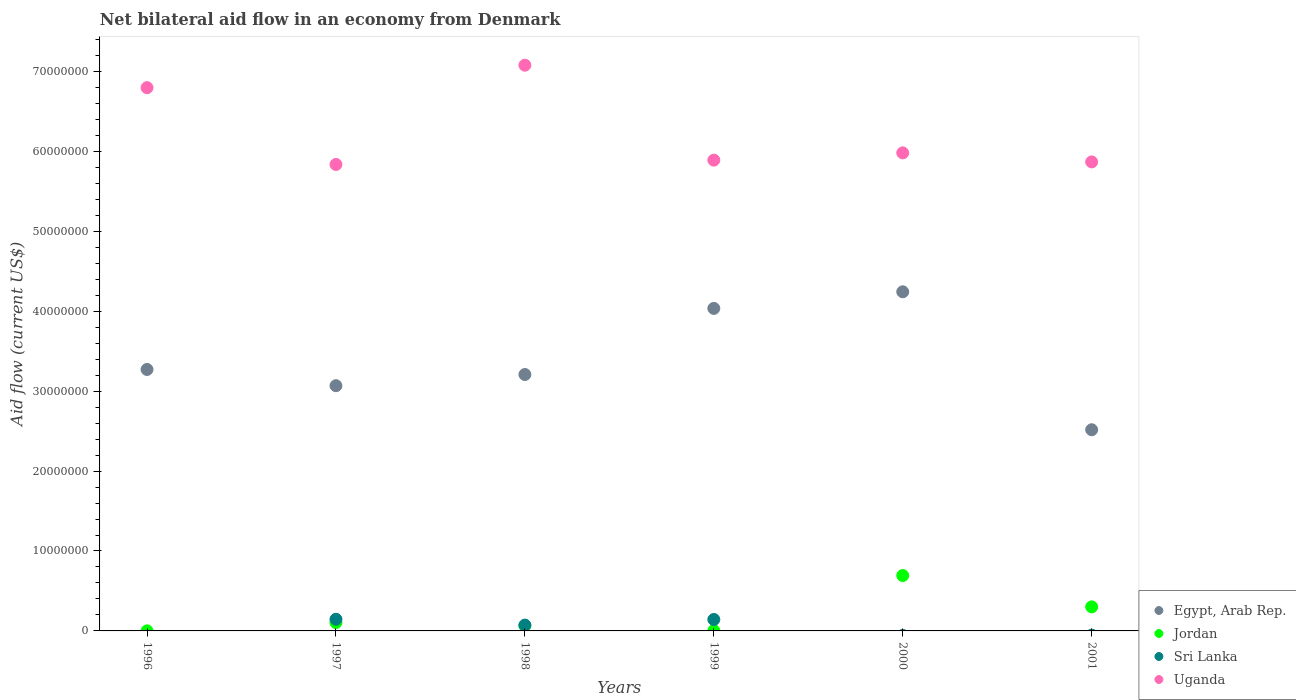How many different coloured dotlines are there?
Provide a short and direct response. 4. What is the net bilateral aid flow in Sri Lanka in 2000?
Keep it short and to the point. 0. Across all years, what is the maximum net bilateral aid flow in Uganda?
Your response must be concise. 7.08e+07. Across all years, what is the minimum net bilateral aid flow in Uganda?
Your answer should be compact. 5.84e+07. What is the total net bilateral aid flow in Jordan in the graph?
Offer a very short reply. 1.17e+07. What is the difference between the net bilateral aid flow in Egypt, Arab Rep. in 1999 and that in 2001?
Make the answer very short. 1.52e+07. What is the difference between the net bilateral aid flow in Uganda in 1999 and the net bilateral aid flow in Egypt, Arab Rep. in 2000?
Make the answer very short. 1.65e+07. What is the average net bilateral aid flow in Uganda per year?
Your answer should be very brief. 6.24e+07. In how many years, is the net bilateral aid flow in Uganda greater than 44000000 US$?
Offer a terse response. 6. What is the ratio of the net bilateral aid flow in Egypt, Arab Rep. in 1999 to that in 2000?
Your answer should be very brief. 0.95. Is the net bilateral aid flow in Egypt, Arab Rep. in 2000 less than that in 2001?
Give a very brief answer. No. Is the difference between the net bilateral aid flow in Sri Lanka in 1997 and 1999 greater than the difference between the net bilateral aid flow in Jordan in 1997 and 1999?
Provide a succinct answer. No. What is the difference between the highest and the second highest net bilateral aid flow in Sri Lanka?
Give a very brief answer. 3.00e+04. What is the difference between the highest and the lowest net bilateral aid flow in Sri Lanka?
Keep it short and to the point. 1.46e+06. In how many years, is the net bilateral aid flow in Sri Lanka greater than the average net bilateral aid flow in Sri Lanka taken over all years?
Make the answer very short. 3. Is it the case that in every year, the sum of the net bilateral aid flow in Jordan and net bilateral aid flow in Sri Lanka  is greater than the sum of net bilateral aid flow in Uganda and net bilateral aid flow in Egypt, Arab Rep.?
Provide a short and direct response. No. Is it the case that in every year, the sum of the net bilateral aid flow in Uganda and net bilateral aid flow in Sri Lanka  is greater than the net bilateral aid flow in Egypt, Arab Rep.?
Your answer should be very brief. Yes. Is the net bilateral aid flow in Egypt, Arab Rep. strictly greater than the net bilateral aid flow in Sri Lanka over the years?
Provide a succinct answer. Yes. How many dotlines are there?
Ensure brevity in your answer.  4. Does the graph contain grids?
Give a very brief answer. No. How many legend labels are there?
Ensure brevity in your answer.  4. What is the title of the graph?
Your answer should be very brief. Net bilateral aid flow in an economy from Denmark. What is the Aid flow (current US$) of Egypt, Arab Rep. in 1996?
Provide a succinct answer. 3.27e+07. What is the Aid flow (current US$) of Uganda in 1996?
Make the answer very short. 6.80e+07. What is the Aid flow (current US$) in Egypt, Arab Rep. in 1997?
Make the answer very short. 3.07e+07. What is the Aid flow (current US$) of Jordan in 1997?
Provide a short and direct response. 1.05e+06. What is the Aid flow (current US$) in Sri Lanka in 1997?
Provide a short and direct response. 1.46e+06. What is the Aid flow (current US$) of Uganda in 1997?
Ensure brevity in your answer.  5.84e+07. What is the Aid flow (current US$) in Egypt, Arab Rep. in 1998?
Your response must be concise. 3.21e+07. What is the Aid flow (current US$) in Jordan in 1998?
Provide a short and direct response. 6.50e+05. What is the Aid flow (current US$) in Sri Lanka in 1998?
Your response must be concise. 7.30e+05. What is the Aid flow (current US$) in Uganda in 1998?
Keep it short and to the point. 7.08e+07. What is the Aid flow (current US$) of Egypt, Arab Rep. in 1999?
Give a very brief answer. 4.04e+07. What is the Aid flow (current US$) in Jordan in 1999?
Your answer should be very brief. 4.00e+04. What is the Aid flow (current US$) of Sri Lanka in 1999?
Your response must be concise. 1.43e+06. What is the Aid flow (current US$) in Uganda in 1999?
Offer a terse response. 5.89e+07. What is the Aid flow (current US$) in Egypt, Arab Rep. in 2000?
Your answer should be very brief. 4.24e+07. What is the Aid flow (current US$) of Jordan in 2000?
Make the answer very short. 6.93e+06. What is the Aid flow (current US$) in Sri Lanka in 2000?
Offer a very short reply. 0. What is the Aid flow (current US$) in Uganda in 2000?
Ensure brevity in your answer.  5.98e+07. What is the Aid flow (current US$) in Egypt, Arab Rep. in 2001?
Provide a succinct answer. 2.52e+07. What is the Aid flow (current US$) in Jordan in 2001?
Make the answer very short. 3.01e+06. What is the Aid flow (current US$) of Sri Lanka in 2001?
Your answer should be compact. 0. What is the Aid flow (current US$) of Uganda in 2001?
Provide a short and direct response. 5.87e+07. Across all years, what is the maximum Aid flow (current US$) of Egypt, Arab Rep.?
Your answer should be compact. 4.24e+07. Across all years, what is the maximum Aid flow (current US$) in Jordan?
Your response must be concise. 6.93e+06. Across all years, what is the maximum Aid flow (current US$) in Sri Lanka?
Offer a very short reply. 1.46e+06. Across all years, what is the maximum Aid flow (current US$) of Uganda?
Provide a succinct answer. 7.08e+07. Across all years, what is the minimum Aid flow (current US$) of Egypt, Arab Rep.?
Your response must be concise. 2.52e+07. Across all years, what is the minimum Aid flow (current US$) in Sri Lanka?
Provide a short and direct response. 0. Across all years, what is the minimum Aid flow (current US$) of Uganda?
Give a very brief answer. 5.84e+07. What is the total Aid flow (current US$) of Egypt, Arab Rep. in the graph?
Your response must be concise. 2.03e+08. What is the total Aid flow (current US$) of Jordan in the graph?
Make the answer very short. 1.17e+07. What is the total Aid flow (current US$) of Sri Lanka in the graph?
Your response must be concise. 3.62e+06. What is the total Aid flow (current US$) in Uganda in the graph?
Offer a terse response. 3.74e+08. What is the difference between the Aid flow (current US$) of Egypt, Arab Rep. in 1996 and that in 1997?
Your answer should be very brief. 2.03e+06. What is the difference between the Aid flow (current US$) of Jordan in 1996 and that in 1997?
Your answer should be compact. -1.04e+06. What is the difference between the Aid flow (current US$) of Uganda in 1996 and that in 1997?
Give a very brief answer. 9.61e+06. What is the difference between the Aid flow (current US$) in Egypt, Arab Rep. in 1996 and that in 1998?
Your answer should be compact. 6.30e+05. What is the difference between the Aid flow (current US$) of Jordan in 1996 and that in 1998?
Your response must be concise. -6.40e+05. What is the difference between the Aid flow (current US$) of Uganda in 1996 and that in 1998?
Offer a very short reply. -2.81e+06. What is the difference between the Aid flow (current US$) of Egypt, Arab Rep. in 1996 and that in 1999?
Your answer should be very brief. -7.64e+06. What is the difference between the Aid flow (current US$) of Uganda in 1996 and that in 1999?
Make the answer very short. 9.07e+06. What is the difference between the Aid flow (current US$) in Egypt, Arab Rep. in 1996 and that in 2000?
Give a very brief answer. -9.72e+06. What is the difference between the Aid flow (current US$) in Jordan in 1996 and that in 2000?
Make the answer very short. -6.92e+06. What is the difference between the Aid flow (current US$) in Uganda in 1996 and that in 2000?
Offer a very short reply. 8.16e+06. What is the difference between the Aid flow (current US$) of Egypt, Arab Rep. in 1996 and that in 2001?
Ensure brevity in your answer.  7.54e+06. What is the difference between the Aid flow (current US$) of Jordan in 1996 and that in 2001?
Your response must be concise. -3.00e+06. What is the difference between the Aid flow (current US$) of Uganda in 1996 and that in 2001?
Your answer should be compact. 9.29e+06. What is the difference between the Aid flow (current US$) of Egypt, Arab Rep. in 1997 and that in 1998?
Provide a succinct answer. -1.40e+06. What is the difference between the Aid flow (current US$) in Sri Lanka in 1997 and that in 1998?
Your answer should be compact. 7.30e+05. What is the difference between the Aid flow (current US$) in Uganda in 1997 and that in 1998?
Give a very brief answer. -1.24e+07. What is the difference between the Aid flow (current US$) in Egypt, Arab Rep. in 1997 and that in 1999?
Offer a very short reply. -9.67e+06. What is the difference between the Aid flow (current US$) of Jordan in 1997 and that in 1999?
Keep it short and to the point. 1.01e+06. What is the difference between the Aid flow (current US$) in Uganda in 1997 and that in 1999?
Ensure brevity in your answer.  -5.40e+05. What is the difference between the Aid flow (current US$) in Egypt, Arab Rep. in 1997 and that in 2000?
Your response must be concise. -1.18e+07. What is the difference between the Aid flow (current US$) of Jordan in 1997 and that in 2000?
Give a very brief answer. -5.88e+06. What is the difference between the Aid flow (current US$) of Uganda in 1997 and that in 2000?
Offer a very short reply. -1.45e+06. What is the difference between the Aid flow (current US$) in Egypt, Arab Rep. in 1997 and that in 2001?
Give a very brief answer. 5.51e+06. What is the difference between the Aid flow (current US$) of Jordan in 1997 and that in 2001?
Offer a terse response. -1.96e+06. What is the difference between the Aid flow (current US$) in Uganda in 1997 and that in 2001?
Offer a terse response. -3.20e+05. What is the difference between the Aid flow (current US$) in Egypt, Arab Rep. in 1998 and that in 1999?
Provide a succinct answer. -8.27e+06. What is the difference between the Aid flow (current US$) in Jordan in 1998 and that in 1999?
Your response must be concise. 6.10e+05. What is the difference between the Aid flow (current US$) of Sri Lanka in 1998 and that in 1999?
Offer a very short reply. -7.00e+05. What is the difference between the Aid flow (current US$) in Uganda in 1998 and that in 1999?
Provide a short and direct response. 1.19e+07. What is the difference between the Aid flow (current US$) in Egypt, Arab Rep. in 1998 and that in 2000?
Give a very brief answer. -1.04e+07. What is the difference between the Aid flow (current US$) of Jordan in 1998 and that in 2000?
Provide a succinct answer. -6.28e+06. What is the difference between the Aid flow (current US$) of Uganda in 1998 and that in 2000?
Provide a short and direct response. 1.10e+07. What is the difference between the Aid flow (current US$) in Egypt, Arab Rep. in 1998 and that in 2001?
Ensure brevity in your answer.  6.91e+06. What is the difference between the Aid flow (current US$) of Jordan in 1998 and that in 2001?
Give a very brief answer. -2.36e+06. What is the difference between the Aid flow (current US$) of Uganda in 1998 and that in 2001?
Your answer should be compact. 1.21e+07. What is the difference between the Aid flow (current US$) of Egypt, Arab Rep. in 1999 and that in 2000?
Your answer should be compact. -2.08e+06. What is the difference between the Aid flow (current US$) of Jordan in 1999 and that in 2000?
Offer a terse response. -6.89e+06. What is the difference between the Aid flow (current US$) of Uganda in 1999 and that in 2000?
Ensure brevity in your answer.  -9.10e+05. What is the difference between the Aid flow (current US$) of Egypt, Arab Rep. in 1999 and that in 2001?
Your answer should be compact. 1.52e+07. What is the difference between the Aid flow (current US$) in Jordan in 1999 and that in 2001?
Your response must be concise. -2.97e+06. What is the difference between the Aid flow (current US$) in Uganda in 1999 and that in 2001?
Provide a short and direct response. 2.20e+05. What is the difference between the Aid flow (current US$) of Egypt, Arab Rep. in 2000 and that in 2001?
Offer a very short reply. 1.73e+07. What is the difference between the Aid flow (current US$) of Jordan in 2000 and that in 2001?
Make the answer very short. 3.92e+06. What is the difference between the Aid flow (current US$) in Uganda in 2000 and that in 2001?
Your answer should be compact. 1.13e+06. What is the difference between the Aid flow (current US$) of Egypt, Arab Rep. in 1996 and the Aid flow (current US$) of Jordan in 1997?
Make the answer very short. 3.17e+07. What is the difference between the Aid flow (current US$) in Egypt, Arab Rep. in 1996 and the Aid flow (current US$) in Sri Lanka in 1997?
Give a very brief answer. 3.12e+07. What is the difference between the Aid flow (current US$) of Egypt, Arab Rep. in 1996 and the Aid flow (current US$) of Uganda in 1997?
Your answer should be very brief. -2.56e+07. What is the difference between the Aid flow (current US$) in Jordan in 1996 and the Aid flow (current US$) in Sri Lanka in 1997?
Make the answer very short. -1.45e+06. What is the difference between the Aid flow (current US$) in Jordan in 1996 and the Aid flow (current US$) in Uganda in 1997?
Your response must be concise. -5.84e+07. What is the difference between the Aid flow (current US$) in Egypt, Arab Rep. in 1996 and the Aid flow (current US$) in Jordan in 1998?
Offer a very short reply. 3.21e+07. What is the difference between the Aid flow (current US$) of Egypt, Arab Rep. in 1996 and the Aid flow (current US$) of Sri Lanka in 1998?
Provide a short and direct response. 3.20e+07. What is the difference between the Aid flow (current US$) of Egypt, Arab Rep. in 1996 and the Aid flow (current US$) of Uganda in 1998?
Keep it short and to the point. -3.81e+07. What is the difference between the Aid flow (current US$) in Jordan in 1996 and the Aid flow (current US$) in Sri Lanka in 1998?
Ensure brevity in your answer.  -7.20e+05. What is the difference between the Aid flow (current US$) of Jordan in 1996 and the Aid flow (current US$) of Uganda in 1998?
Offer a terse response. -7.08e+07. What is the difference between the Aid flow (current US$) of Egypt, Arab Rep. in 1996 and the Aid flow (current US$) of Jordan in 1999?
Keep it short and to the point. 3.27e+07. What is the difference between the Aid flow (current US$) in Egypt, Arab Rep. in 1996 and the Aid flow (current US$) in Sri Lanka in 1999?
Your answer should be very brief. 3.13e+07. What is the difference between the Aid flow (current US$) in Egypt, Arab Rep. in 1996 and the Aid flow (current US$) in Uganda in 1999?
Your response must be concise. -2.62e+07. What is the difference between the Aid flow (current US$) of Jordan in 1996 and the Aid flow (current US$) of Sri Lanka in 1999?
Offer a terse response. -1.42e+06. What is the difference between the Aid flow (current US$) of Jordan in 1996 and the Aid flow (current US$) of Uganda in 1999?
Keep it short and to the point. -5.89e+07. What is the difference between the Aid flow (current US$) of Egypt, Arab Rep. in 1996 and the Aid flow (current US$) of Jordan in 2000?
Your answer should be compact. 2.58e+07. What is the difference between the Aid flow (current US$) of Egypt, Arab Rep. in 1996 and the Aid flow (current US$) of Uganda in 2000?
Make the answer very short. -2.71e+07. What is the difference between the Aid flow (current US$) in Jordan in 1996 and the Aid flow (current US$) in Uganda in 2000?
Provide a short and direct response. -5.98e+07. What is the difference between the Aid flow (current US$) in Egypt, Arab Rep. in 1996 and the Aid flow (current US$) in Jordan in 2001?
Offer a terse response. 2.97e+07. What is the difference between the Aid flow (current US$) of Egypt, Arab Rep. in 1996 and the Aid flow (current US$) of Uganda in 2001?
Your answer should be very brief. -2.60e+07. What is the difference between the Aid flow (current US$) of Jordan in 1996 and the Aid flow (current US$) of Uganda in 2001?
Your response must be concise. -5.87e+07. What is the difference between the Aid flow (current US$) in Egypt, Arab Rep. in 1997 and the Aid flow (current US$) in Jordan in 1998?
Keep it short and to the point. 3.00e+07. What is the difference between the Aid flow (current US$) in Egypt, Arab Rep. in 1997 and the Aid flow (current US$) in Sri Lanka in 1998?
Your answer should be compact. 3.00e+07. What is the difference between the Aid flow (current US$) of Egypt, Arab Rep. in 1997 and the Aid flow (current US$) of Uganda in 1998?
Ensure brevity in your answer.  -4.01e+07. What is the difference between the Aid flow (current US$) of Jordan in 1997 and the Aid flow (current US$) of Uganda in 1998?
Offer a very short reply. -6.97e+07. What is the difference between the Aid flow (current US$) of Sri Lanka in 1997 and the Aid flow (current US$) of Uganda in 1998?
Your answer should be very brief. -6.93e+07. What is the difference between the Aid flow (current US$) in Egypt, Arab Rep. in 1997 and the Aid flow (current US$) in Jordan in 1999?
Provide a short and direct response. 3.06e+07. What is the difference between the Aid flow (current US$) of Egypt, Arab Rep. in 1997 and the Aid flow (current US$) of Sri Lanka in 1999?
Make the answer very short. 2.92e+07. What is the difference between the Aid flow (current US$) in Egypt, Arab Rep. in 1997 and the Aid flow (current US$) in Uganda in 1999?
Offer a terse response. -2.82e+07. What is the difference between the Aid flow (current US$) of Jordan in 1997 and the Aid flow (current US$) of Sri Lanka in 1999?
Provide a short and direct response. -3.80e+05. What is the difference between the Aid flow (current US$) in Jordan in 1997 and the Aid flow (current US$) in Uganda in 1999?
Offer a very short reply. -5.78e+07. What is the difference between the Aid flow (current US$) in Sri Lanka in 1997 and the Aid flow (current US$) in Uganda in 1999?
Provide a short and direct response. -5.74e+07. What is the difference between the Aid flow (current US$) in Egypt, Arab Rep. in 1997 and the Aid flow (current US$) in Jordan in 2000?
Offer a very short reply. 2.38e+07. What is the difference between the Aid flow (current US$) of Egypt, Arab Rep. in 1997 and the Aid flow (current US$) of Uganda in 2000?
Provide a short and direct response. -2.91e+07. What is the difference between the Aid flow (current US$) in Jordan in 1997 and the Aid flow (current US$) in Uganda in 2000?
Your response must be concise. -5.88e+07. What is the difference between the Aid flow (current US$) in Sri Lanka in 1997 and the Aid flow (current US$) in Uganda in 2000?
Make the answer very short. -5.84e+07. What is the difference between the Aid flow (current US$) in Egypt, Arab Rep. in 1997 and the Aid flow (current US$) in Jordan in 2001?
Offer a terse response. 2.77e+07. What is the difference between the Aid flow (current US$) of Egypt, Arab Rep. in 1997 and the Aid flow (current US$) of Uganda in 2001?
Your answer should be very brief. -2.80e+07. What is the difference between the Aid flow (current US$) in Jordan in 1997 and the Aid flow (current US$) in Uganda in 2001?
Give a very brief answer. -5.76e+07. What is the difference between the Aid flow (current US$) in Sri Lanka in 1997 and the Aid flow (current US$) in Uganda in 2001?
Provide a short and direct response. -5.72e+07. What is the difference between the Aid flow (current US$) in Egypt, Arab Rep. in 1998 and the Aid flow (current US$) in Jordan in 1999?
Your answer should be very brief. 3.20e+07. What is the difference between the Aid flow (current US$) in Egypt, Arab Rep. in 1998 and the Aid flow (current US$) in Sri Lanka in 1999?
Ensure brevity in your answer.  3.06e+07. What is the difference between the Aid flow (current US$) in Egypt, Arab Rep. in 1998 and the Aid flow (current US$) in Uganda in 1999?
Provide a short and direct response. -2.68e+07. What is the difference between the Aid flow (current US$) in Jordan in 1998 and the Aid flow (current US$) in Sri Lanka in 1999?
Provide a short and direct response. -7.80e+05. What is the difference between the Aid flow (current US$) of Jordan in 1998 and the Aid flow (current US$) of Uganda in 1999?
Ensure brevity in your answer.  -5.82e+07. What is the difference between the Aid flow (current US$) of Sri Lanka in 1998 and the Aid flow (current US$) of Uganda in 1999?
Your response must be concise. -5.82e+07. What is the difference between the Aid flow (current US$) in Egypt, Arab Rep. in 1998 and the Aid flow (current US$) in Jordan in 2000?
Provide a succinct answer. 2.52e+07. What is the difference between the Aid flow (current US$) in Egypt, Arab Rep. in 1998 and the Aid flow (current US$) in Uganda in 2000?
Your answer should be compact. -2.77e+07. What is the difference between the Aid flow (current US$) in Jordan in 1998 and the Aid flow (current US$) in Uganda in 2000?
Keep it short and to the point. -5.92e+07. What is the difference between the Aid flow (current US$) in Sri Lanka in 1998 and the Aid flow (current US$) in Uganda in 2000?
Provide a short and direct response. -5.91e+07. What is the difference between the Aid flow (current US$) in Egypt, Arab Rep. in 1998 and the Aid flow (current US$) in Jordan in 2001?
Your answer should be very brief. 2.91e+07. What is the difference between the Aid flow (current US$) in Egypt, Arab Rep. in 1998 and the Aid flow (current US$) in Uganda in 2001?
Offer a very short reply. -2.66e+07. What is the difference between the Aid flow (current US$) in Jordan in 1998 and the Aid flow (current US$) in Uganda in 2001?
Keep it short and to the point. -5.80e+07. What is the difference between the Aid flow (current US$) in Sri Lanka in 1998 and the Aid flow (current US$) in Uganda in 2001?
Provide a succinct answer. -5.80e+07. What is the difference between the Aid flow (current US$) of Egypt, Arab Rep. in 1999 and the Aid flow (current US$) of Jordan in 2000?
Keep it short and to the point. 3.34e+07. What is the difference between the Aid flow (current US$) in Egypt, Arab Rep. in 1999 and the Aid flow (current US$) in Uganda in 2000?
Your answer should be very brief. -1.95e+07. What is the difference between the Aid flow (current US$) in Jordan in 1999 and the Aid flow (current US$) in Uganda in 2000?
Your answer should be very brief. -5.98e+07. What is the difference between the Aid flow (current US$) of Sri Lanka in 1999 and the Aid flow (current US$) of Uganda in 2000?
Ensure brevity in your answer.  -5.84e+07. What is the difference between the Aid flow (current US$) of Egypt, Arab Rep. in 1999 and the Aid flow (current US$) of Jordan in 2001?
Make the answer very short. 3.73e+07. What is the difference between the Aid flow (current US$) of Egypt, Arab Rep. in 1999 and the Aid flow (current US$) of Uganda in 2001?
Offer a terse response. -1.83e+07. What is the difference between the Aid flow (current US$) of Jordan in 1999 and the Aid flow (current US$) of Uganda in 2001?
Offer a very short reply. -5.86e+07. What is the difference between the Aid flow (current US$) of Sri Lanka in 1999 and the Aid flow (current US$) of Uganda in 2001?
Provide a succinct answer. -5.72e+07. What is the difference between the Aid flow (current US$) of Egypt, Arab Rep. in 2000 and the Aid flow (current US$) of Jordan in 2001?
Offer a very short reply. 3.94e+07. What is the difference between the Aid flow (current US$) of Egypt, Arab Rep. in 2000 and the Aid flow (current US$) of Uganda in 2001?
Make the answer very short. -1.62e+07. What is the difference between the Aid flow (current US$) of Jordan in 2000 and the Aid flow (current US$) of Uganda in 2001?
Provide a short and direct response. -5.18e+07. What is the average Aid flow (current US$) of Egypt, Arab Rep. per year?
Your response must be concise. 3.39e+07. What is the average Aid flow (current US$) in Jordan per year?
Provide a short and direct response. 1.95e+06. What is the average Aid flow (current US$) in Sri Lanka per year?
Provide a succinct answer. 6.03e+05. What is the average Aid flow (current US$) in Uganda per year?
Provide a short and direct response. 6.24e+07. In the year 1996, what is the difference between the Aid flow (current US$) of Egypt, Arab Rep. and Aid flow (current US$) of Jordan?
Provide a succinct answer. 3.27e+07. In the year 1996, what is the difference between the Aid flow (current US$) of Egypt, Arab Rep. and Aid flow (current US$) of Uganda?
Your response must be concise. -3.53e+07. In the year 1996, what is the difference between the Aid flow (current US$) of Jordan and Aid flow (current US$) of Uganda?
Provide a succinct answer. -6.80e+07. In the year 1997, what is the difference between the Aid flow (current US$) in Egypt, Arab Rep. and Aid flow (current US$) in Jordan?
Offer a terse response. 2.96e+07. In the year 1997, what is the difference between the Aid flow (current US$) in Egypt, Arab Rep. and Aid flow (current US$) in Sri Lanka?
Provide a short and direct response. 2.92e+07. In the year 1997, what is the difference between the Aid flow (current US$) in Egypt, Arab Rep. and Aid flow (current US$) in Uganda?
Provide a succinct answer. -2.77e+07. In the year 1997, what is the difference between the Aid flow (current US$) of Jordan and Aid flow (current US$) of Sri Lanka?
Provide a short and direct response. -4.10e+05. In the year 1997, what is the difference between the Aid flow (current US$) of Jordan and Aid flow (current US$) of Uganda?
Ensure brevity in your answer.  -5.73e+07. In the year 1997, what is the difference between the Aid flow (current US$) in Sri Lanka and Aid flow (current US$) in Uganda?
Your response must be concise. -5.69e+07. In the year 1998, what is the difference between the Aid flow (current US$) of Egypt, Arab Rep. and Aid flow (current US$) of Jordan?
Offer a terse response. 3.14e+07. In the year 1998, what is the difference between the Aid flow (current US$) of Egypt, Arab Rep. and Aid flow (current US$) of Sri Lanka?
Give a very brief answer. 3.14e+07. In the year 1998, what is the difference between the Aid flow (current US$) in Egypt, Arab Rep. and Aid flow (current US$) in Uganda?
Your answer should be compact. -3.87e+07. In the year 1998, what is the difference between the Aid flow (current US$) of Jordan and Aid flow (current US$) of Sri Lanka?
Your response must be concise. -8.00e+04. In the year 1998, what is the difference between the Aid flow (current US$) in Jordan and Aid flow (current US$) in Uganda?
Keep it short and to the point. -7.01e+07. In the year 1998, what is the difference between the Aid flow (current US$) of Sri Lanka and Aid flow (current US$) of Uganda?
Ensure brevity in your answer.  -7.00e+07. In the year 1999, what is the difference between the Aid flow (current US$) of Egypt, Arab Rep. and Aid flow (current US$) of Jordan?
Make the answer very short. 4.03e+07. In the year 1999, what is the difference between the Aid flow (current US$) in Egypt, Arab Rep. and Aid flow (current US$) in Sri Lanka?
Offer a terse response. 3.89e+07. In the year 1999, what is the difference between the Aid flow (current US$) of Egypt, Arab Rep. and Aid flow (current US$) of Uganda?
Offer a terse response. -1.86e+07. In the year 1999, what is the difference between the Aid flow (current US$) of Jordan and Aid flow (current US$) of Sri Lanka?
Offer a terse response. -1.39e+06. In the year 1999, what is the difference between the Aid flow (current US$) in Jordan and Aid flow (current US$) in Uganda?
Your answer should be very brief. -5.89e+07. In the year 1999, what is the difference between the Aid flow (current US$) in Sri Lanka and Aid flow (current US$) in Uganda?
Offer a very short reply. -5.75e+07. In the year 2000, what is the difference between the Aid flow (current US$) in Egypt, Arab Rep. and Aid flow (current US$) in Jordan?
Provide a short and direct response. 3.55e+07. In the year 2000, what is the difference between the Aid flow (current US$) of Egypt, Arab Rep. and Aid flow (current US$) of Uganda?
Your answer should be very brief. -1.74e+07. In the year 2000, what is the difference between the Aid flow (current US$) in Jordan and Aid flow (current US$) in Uganda?
Provide a succinct answer. -5.29e+07. In the year 2001, what is the difference between the Aid flow (current US$) in Egypt, Arab Rep. and Aid flow (current US$) in Jordan?
Provide a succinct answer. 2.22e+07. In the year 2001, what is the difference between the Aid flow (current US$) in Egypt, Arab Rep. and Aid flow (current US$) in Uganda?
Make the answer very short. -3.35e+07. In the year 2001, what is the difference between the Aid flow (current US$) in Jordan and Aid flow (current US$) in Uganda?
Make the answer very short. -5.57e+07. What is the ratio of the Aid flow (current US$) in Egypt, Arab Rep. in 1996 to that in 1997?
Your response must be concise. 1.07. What is the ratio of the Aid flow (current US$) of Jordan in 1996 to that in 1997?
Give a very brief answer. 0.01. What is the ratio of the Aid flow (current US$) in Uganda in 1996 to that in 1997?
Your answer should be very brief. 1.16. What is the ratio of the Aid flow (current US$) in Egypt, Arab Rep. in 1996 to that in 1998?
Make the answer very short. 1.02. What is the ratio of the Aid flow (current US$) in Jordan in 1996 to that in 1998?
Your response must be concise. 0.02. What is the ratio of the Aid flow (current US$) of Uganda in 1996 to that in 1998?
Make the answer very short. 0.96. What is the ratio of the Aid flow (current US$) in Egypt, Arab Rep. in 1996 to that in 1999?
Give a very brief answer. 0.81. What is the ratio of the Aid flow (current US$) in Uganda in 1996 to that in 1999?
Your answer should be very brief. 1.15. What is the ratio of the Aid flow (current US$) of Egypt, Arab Rep. in 1996 to that in 2000?
Keep it short and to the point. 0.77. What is the ratio of the Aid flow (current US$) of Jordan in 1996 to that in 2000?
Provide a succinct answer. 0. What is the ratio of the Aid flow (current US$) in Uganda in 1996 to that in 2000?
Give a very brief answer. 1.14. What is the ratio of the Aid flow (current US$) of Egypt, Arab Rep. in 1996 to that in 2001?
Ensure brevity in your answer.  1.3. What is the ratio of the Aid flow (current US$) of Jordan in 1996 to that in 2001?
Offer a very short reply. 0. What is the ratio of the Aid flow (current US$) in Uganda in 1996 to that in 2001?
Keep it short and to the point. 1.16. What is the ratio of the Aid flow (current US$) in Egypt, Arab Rep. in 1997 to that in 1998?
Make the answer very short. 0.96. What is the ratio of the Aid flow (current US$) in Jordan in 1997 to that in 1998?
Ensure brevity in your answer.  1.62. What is the ratio of the Aid flow (current US$) in Uganda in 1997 to that in 1998?
Offer a very short reply. 0.82. What is the ratio of the Aid flow (current US$) of Egypt, Arab Rep. in 1997 to that in 1999?
Offer a terse response. 0.76. What is the ratio of the Aid flow (current US$) in Jordan in 1997 to that in 1999?
Make the answer very short. 26.25. What is the ratio of the Aid flow (current US$) of Egypt, Arab Rep. in 1997 to that in 2000?
Offer a terse response. 0.72. What is the ratio of the Aid flow (current US$) of Jordan in 1997 to that in 2000?
Offer a terse response. 0.15. What is the ratio of the Aid flow (current US$) of Uganda in 1997 to that in 2000?
Make the answer very short. 0.98. What is the ratio of the Aid flow (current US$) of Egypt, Arab Rep. in 1997 to that in 2001?
Your response must be concise. 1.22. What is the ratio of the Aid flow (current US$) in Jordan in 1997 to that in 2001?
Ensure brevity in your answer.  0.35. What is the ratio of the Aid flow (current US$) in Egypt, Arab Rep. in 1998 to that in 1999?
Your answer should be very brief. 0.8. What is the ratio of the Aid flow (current US$) in Jordan in 1998 to that in 1999?
Give a very brief answer. 16.25. What is the ratio of the Aid flow (current US$) in Sri Lanka in 1998 to that in 1999?
Provide a succinct answer. 0.51. What is the ratio of the Aid flow (current US$) of Uganda in 1998 to that in 1999?
Provide a short and direct response. 1.2. What is the ratio of the Aid flow (current US$) of Egypt, Arab Rep. in 1998 to that in 2000?
Make the answer very short. 0.76. What is the ratio of the Aid flow (current US$) of Jordan in 1998 to that in 2000?
Give a very brief answer. 0.09. What is the ratio of the Aid flow (current US$) of Uganda in 1998 to that in 2000?
Provide a succinct answer. 1.18. What is the ratio of the Aid flow (current US$) of Egypt, Arab Rep. in 1998 to that in 2001?
Your answer should be compact. 1.27. What is the ratio of the Aid flow (current US$) of Jordan in 1998 to that in 2001?
Offer a very short reply. 0.22. What is the ratio of the Aid flow (current US$) in Uganda in 1998 to that in 2001?
Your response must be concise. 1.21. What is the ratio of the Aid flow (current US$) in Egypt, Arab Rep. in 1999 to that in 2000?
Offer a terse response. 0.95. What is the ratio of the Aid flow (current US$) in Jordan in 1999 to that in 2000?
Give a very brief answer. 0.01. What is the ratio of the Aid flow (current US$) in Egypt, Arab Rep. in 1999 to that in 2001?
Provide a succinct answer. 1.6. What is the ratio of the Aid flow (current US$) in Jordan in 1999 to that in 2001?
Your answer should be very brief. 0.01. What is the ratio of the Aid flow (current US$) in Uganda in 1999 to that in 2001?
Make the answer very short. 1. What is the ratio of the Aid flow (current US$) of Egypt, Arab Rep. in 2000 to that in 2001?
Offer a terse response. 1.69. What is the ratio of the Aid flow (current US$) of Jordan in 2000 to that in 2001?
Ensure brevity in your answer.  2.3. What is the ratio of the Aid flow (current US$) in Uganda in 2000 to that in 2001?
Your response must be concise. 1.02. What is the difference between the highest and the second highest Aid flow (current US$) in Egypt, Arab Rep.?
Your answer should be compact. 2.08e+06. What is the difference between the highest and the second highest Aid flow (current US$) in Jordan?
Offer a very short reply. 3.92e+06. What is the difference between the highest and the second highest Aid flow (current US$) in Uganda?
Make the answer very short. 2.81e+06. What is the difference between the highest and the lowest Aid flow (current US$) of Egypt, Arab Rep.?
Your response must be concise. 1.73e+07. What is the difference between the highest and the lowest Aid flow (current US$) in Jordan?
Your answer should be compact. 6.92e+06. What is the difference between the highest and the lowest Aid flow (current US$) of Sri Lanka?
Make the answer very short. 1.46e+06. What is the difference between the highest and the lowest Aid flow (current US$) of Uganda?
Your answer should be compact. 1.24e+07. 